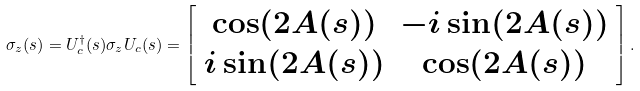<formula> <loc_0><loc_0><loc_500><loc_500>\sigma _ { z } ( s ) = U ^ { \dagger } _ { c } ( s ) \sigma _ { z } U _ { c } ( s ) = \left [ \begin{array} { c c } \cos ( 2 A ( s ) ) & - i \sin ( 2 A ( s ) ) \\ i \sin ( 2 A ( s ) ) & \cos ( 2 A ( s ) ) \end{array} \right ] .</formula> 